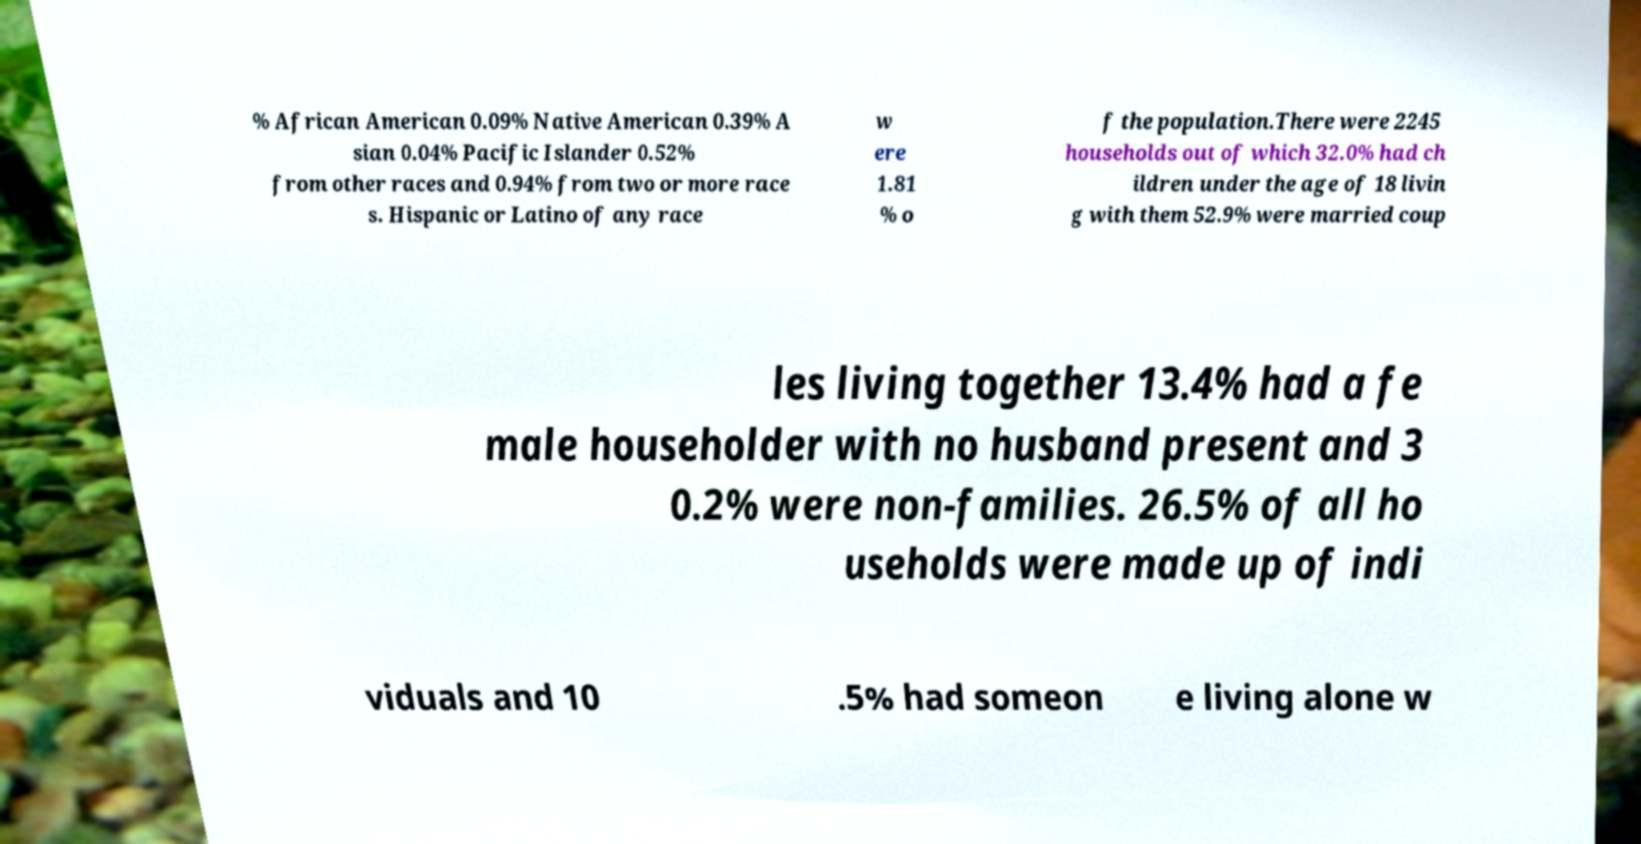Can you accurately transcribe the text from the provided image for me? % African American 0.09% Native American 0.39% A sian 0.04% Pacific Islander 0.52% from other races and 0.94% from two or more race s. Hispanic or Latino of any race w ere 1.81 % o f the population.There were 2245 households out of which 32.0% had ch ildren under the age of 18 livin g with them 52.9% were married coup les living together 13.4% had a fe male householder with no husband present and 3 0.2% were non-families. 26.5% of all ho useholds were made up of indi viduals and 10 .5% had someon e living alone w 